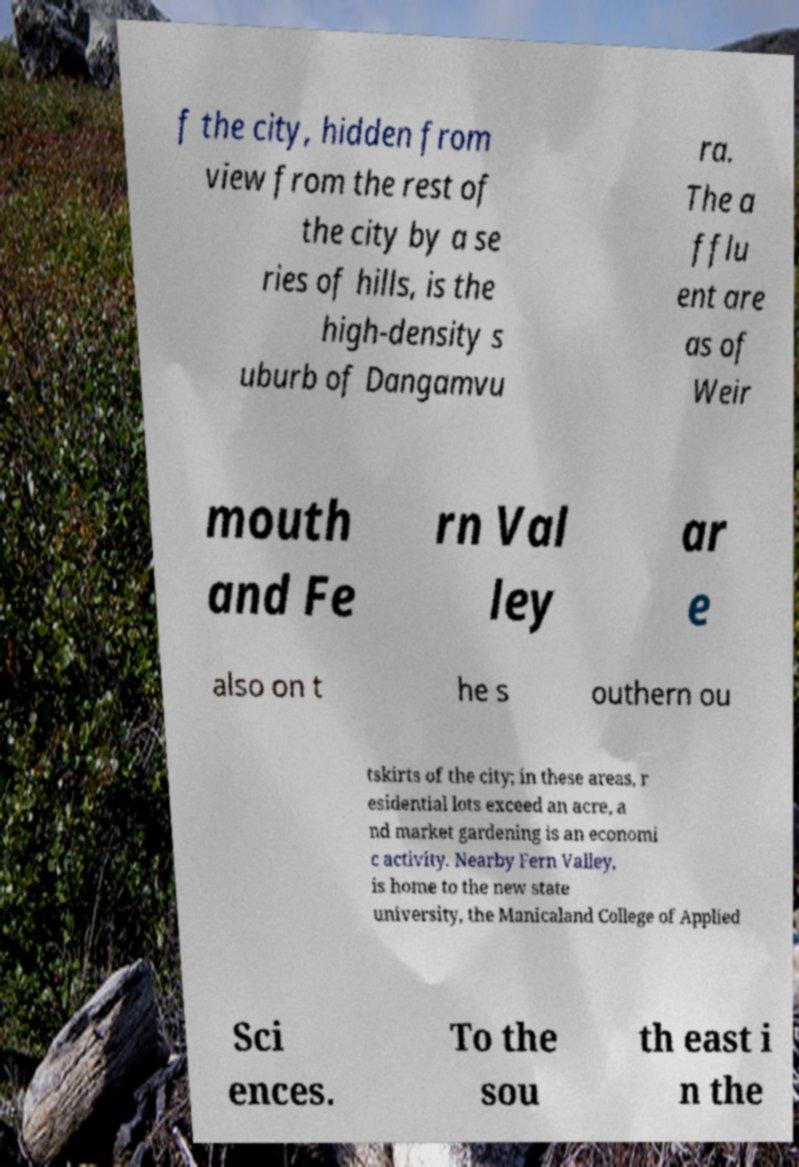For documentation purposes, I need the text within this image transcribed. Could you provide that? f the city, hidden from view from the rest of the city by a se ries of hills, is the high-density s uburb of Dangamvu ra. The a fflu ent are as of Weir mouth and Fe rn Val ley ar e also on t he s outhern ou tskirts of the city; in these areas, r esidential lots exceed an acre, a nd market gardening is an economi c activity. Nearby Fern Valley, is home to the new state university, the Manicaland College of Applied Sci ences. To the sou th east i n the 